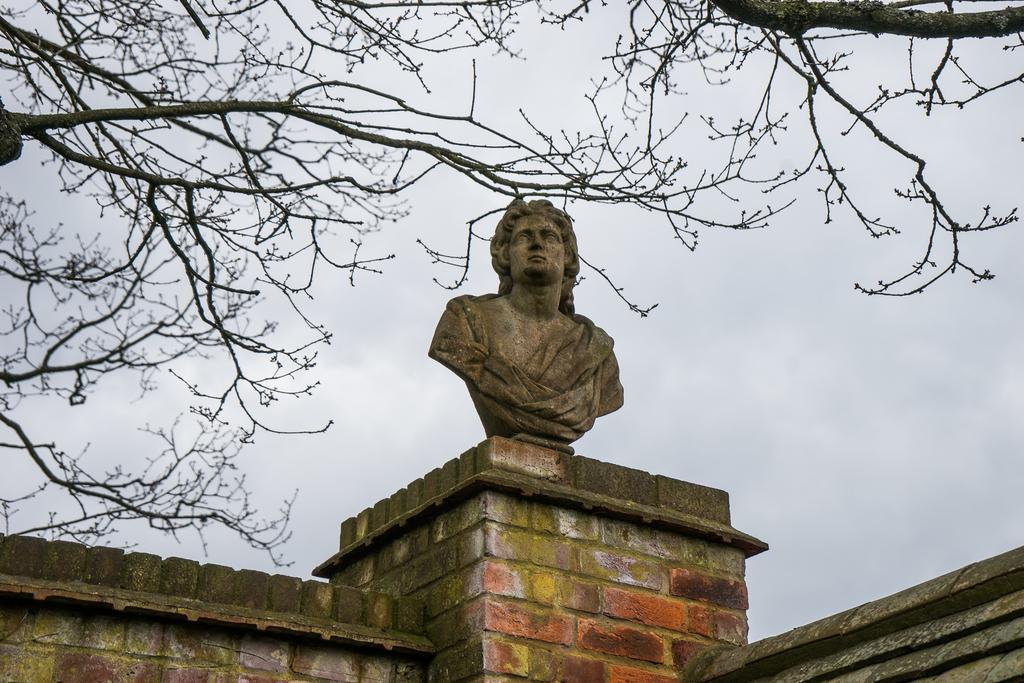What is on the wall in the image? There is a statue on the wall in the image. What can be seen in the background of the image? There are trees and the sky visible in the background of the image. What caption is written below the statue in the image? There is no caption visible in the image; it only shows a statue on the wall and the background. 